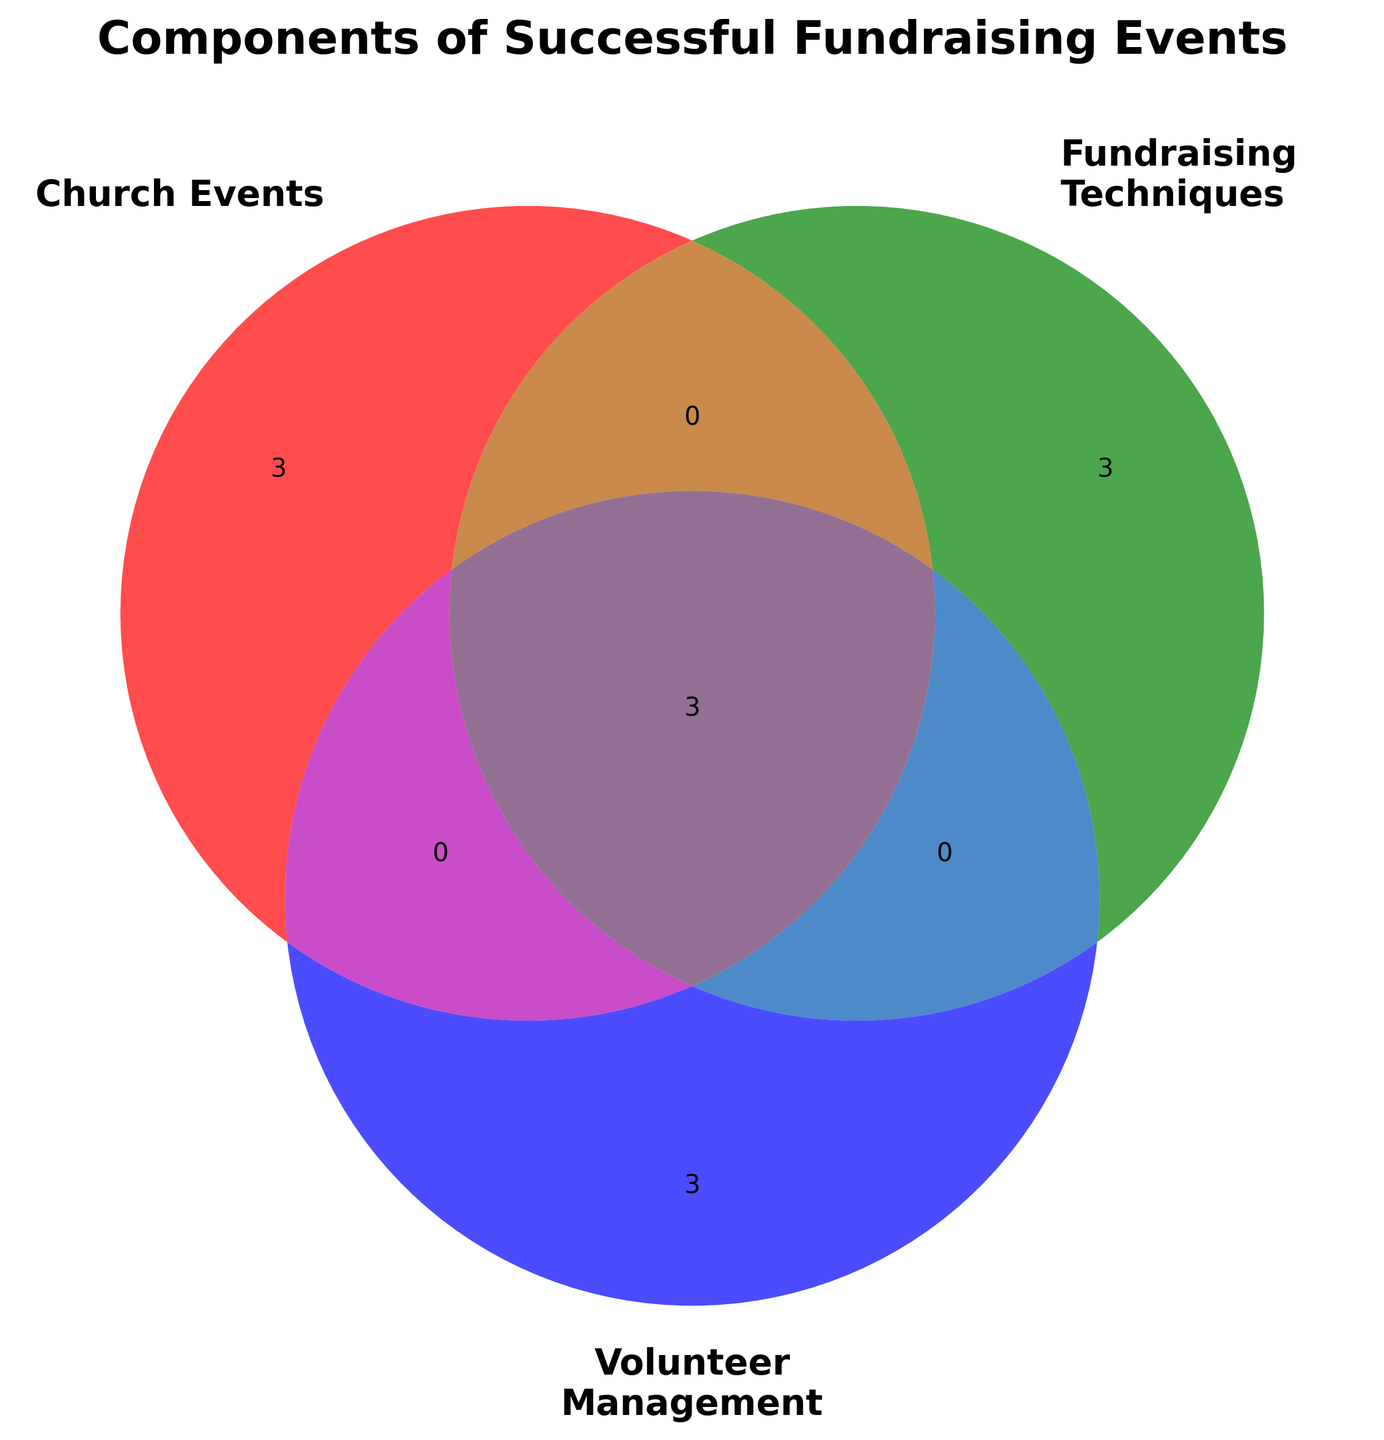What are the titles of the three sets in the Venn diagram? The titles of the sets are directly labeled on the Venn diagram. They are: 'Church Events', 'Fundraising Techniques', and 'Volunteer Management'.
Answer: Church Events, Fundraising Techniques, Volunteer Management How many categories are shared by all three sets? Look at the intersection area of all three circles in the Venn diagram. This area covers the three items under 'All Categories' shared by all sets.
Answer: Three Which category is shared between Church Events and Fundraising Techniques but not Volunteer Management? Check the intersection area between Church Events and Fundraising Techniques only. The item in this shared region should not be in Volunteer Management.
Answer: None Are there any categories unique to the Volunteer Management set? Focus on the portion of the Venn diagram representing Volunteer Management only. Items located in this section are unique to Volunteer Management.
Answer: Yes Which components fall under both Fundraising Techniques and Volunteer Management? Inspect the intersection between the Fundraising Techniques and Volunteer Management circles. Items there are shared by both categories.
Answer: Budget Management, Advertising, Event Planning How many items are exclusive to the Church Events category? Look at the segment of the Venn diagram representing only Church Events and count items listed there.
Answer: Three What is the shared component between all categories and Fundraising Techniques only? Look at the areas where Fundraising Techniques intersect with all three sets. Identify the items that are in Fundraising Techniques and the 'All Categories'.
Answer: Event Planning, Advertising, Budget Management Which individual sections highlight the unique categories for each set? Locate the non-overlapping sections of each set in the Venn diagram. These sections will contain items exclusive to that particular set.
Answer: Sections for Prayer Gatherings, Seasonal Celebrations, Community Outreach, Silent Auctions, Donation Appeals, Sponsorship Programs, Task Assignment, Recognition Programs, Training Sessions Which components do Church Events and Volunteer Management share apart from those in all categories? Look at the overlapping area of Church Events and Volunteer Management excluding the central intersection with all categories.
Answer: None What is the total number of items considered in the figure? Add the number of items across all labeled sections while avoiding double-counting shared items.
Answer: Twelve 